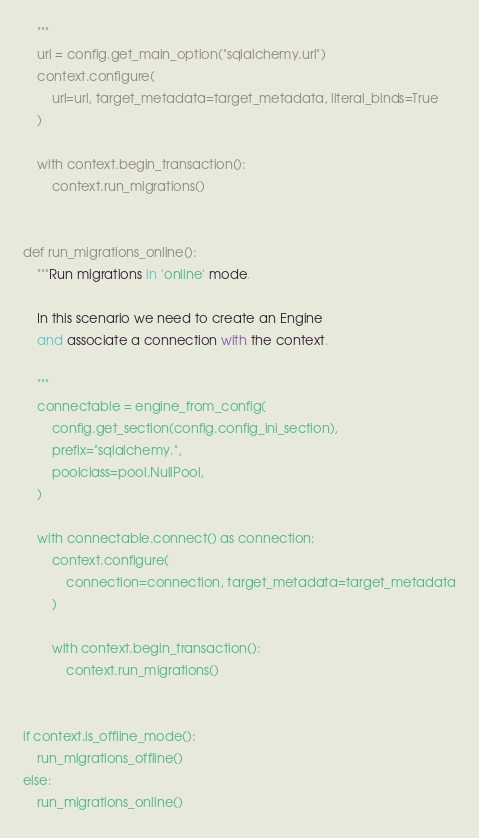<code> <loc_0><loc_0><loc_500><loc_500><_Python_>    """
    url = config.get_main_option("sqlalchemy.url")
    context.configure(
        url=url, target_metadata=target_metadata, literal_binds=True
    )

    with context.begin_transaction():
        context.run_migrations()


def run_migrations_online():
    """Run migrations in 'online' mode.

    In this scenario we need to create an Engine
    and associate a connection with the context.

    """
    connectable = engine_from_config(
        config.get_section(config.config_ini_section),
        prefix="sqlalchemy.",
        poolclass=pool.NullPool,
    )

    with connectable.connect() as connection:
        context.configure(
            connection=connection, target_metadata=target_metadata
        )

        with context.begin_transaction():
            context.run_migrations()


if context.is_offline_mode():
    run_migrations_offline()
else:
    run_migrations_online()
</code> 